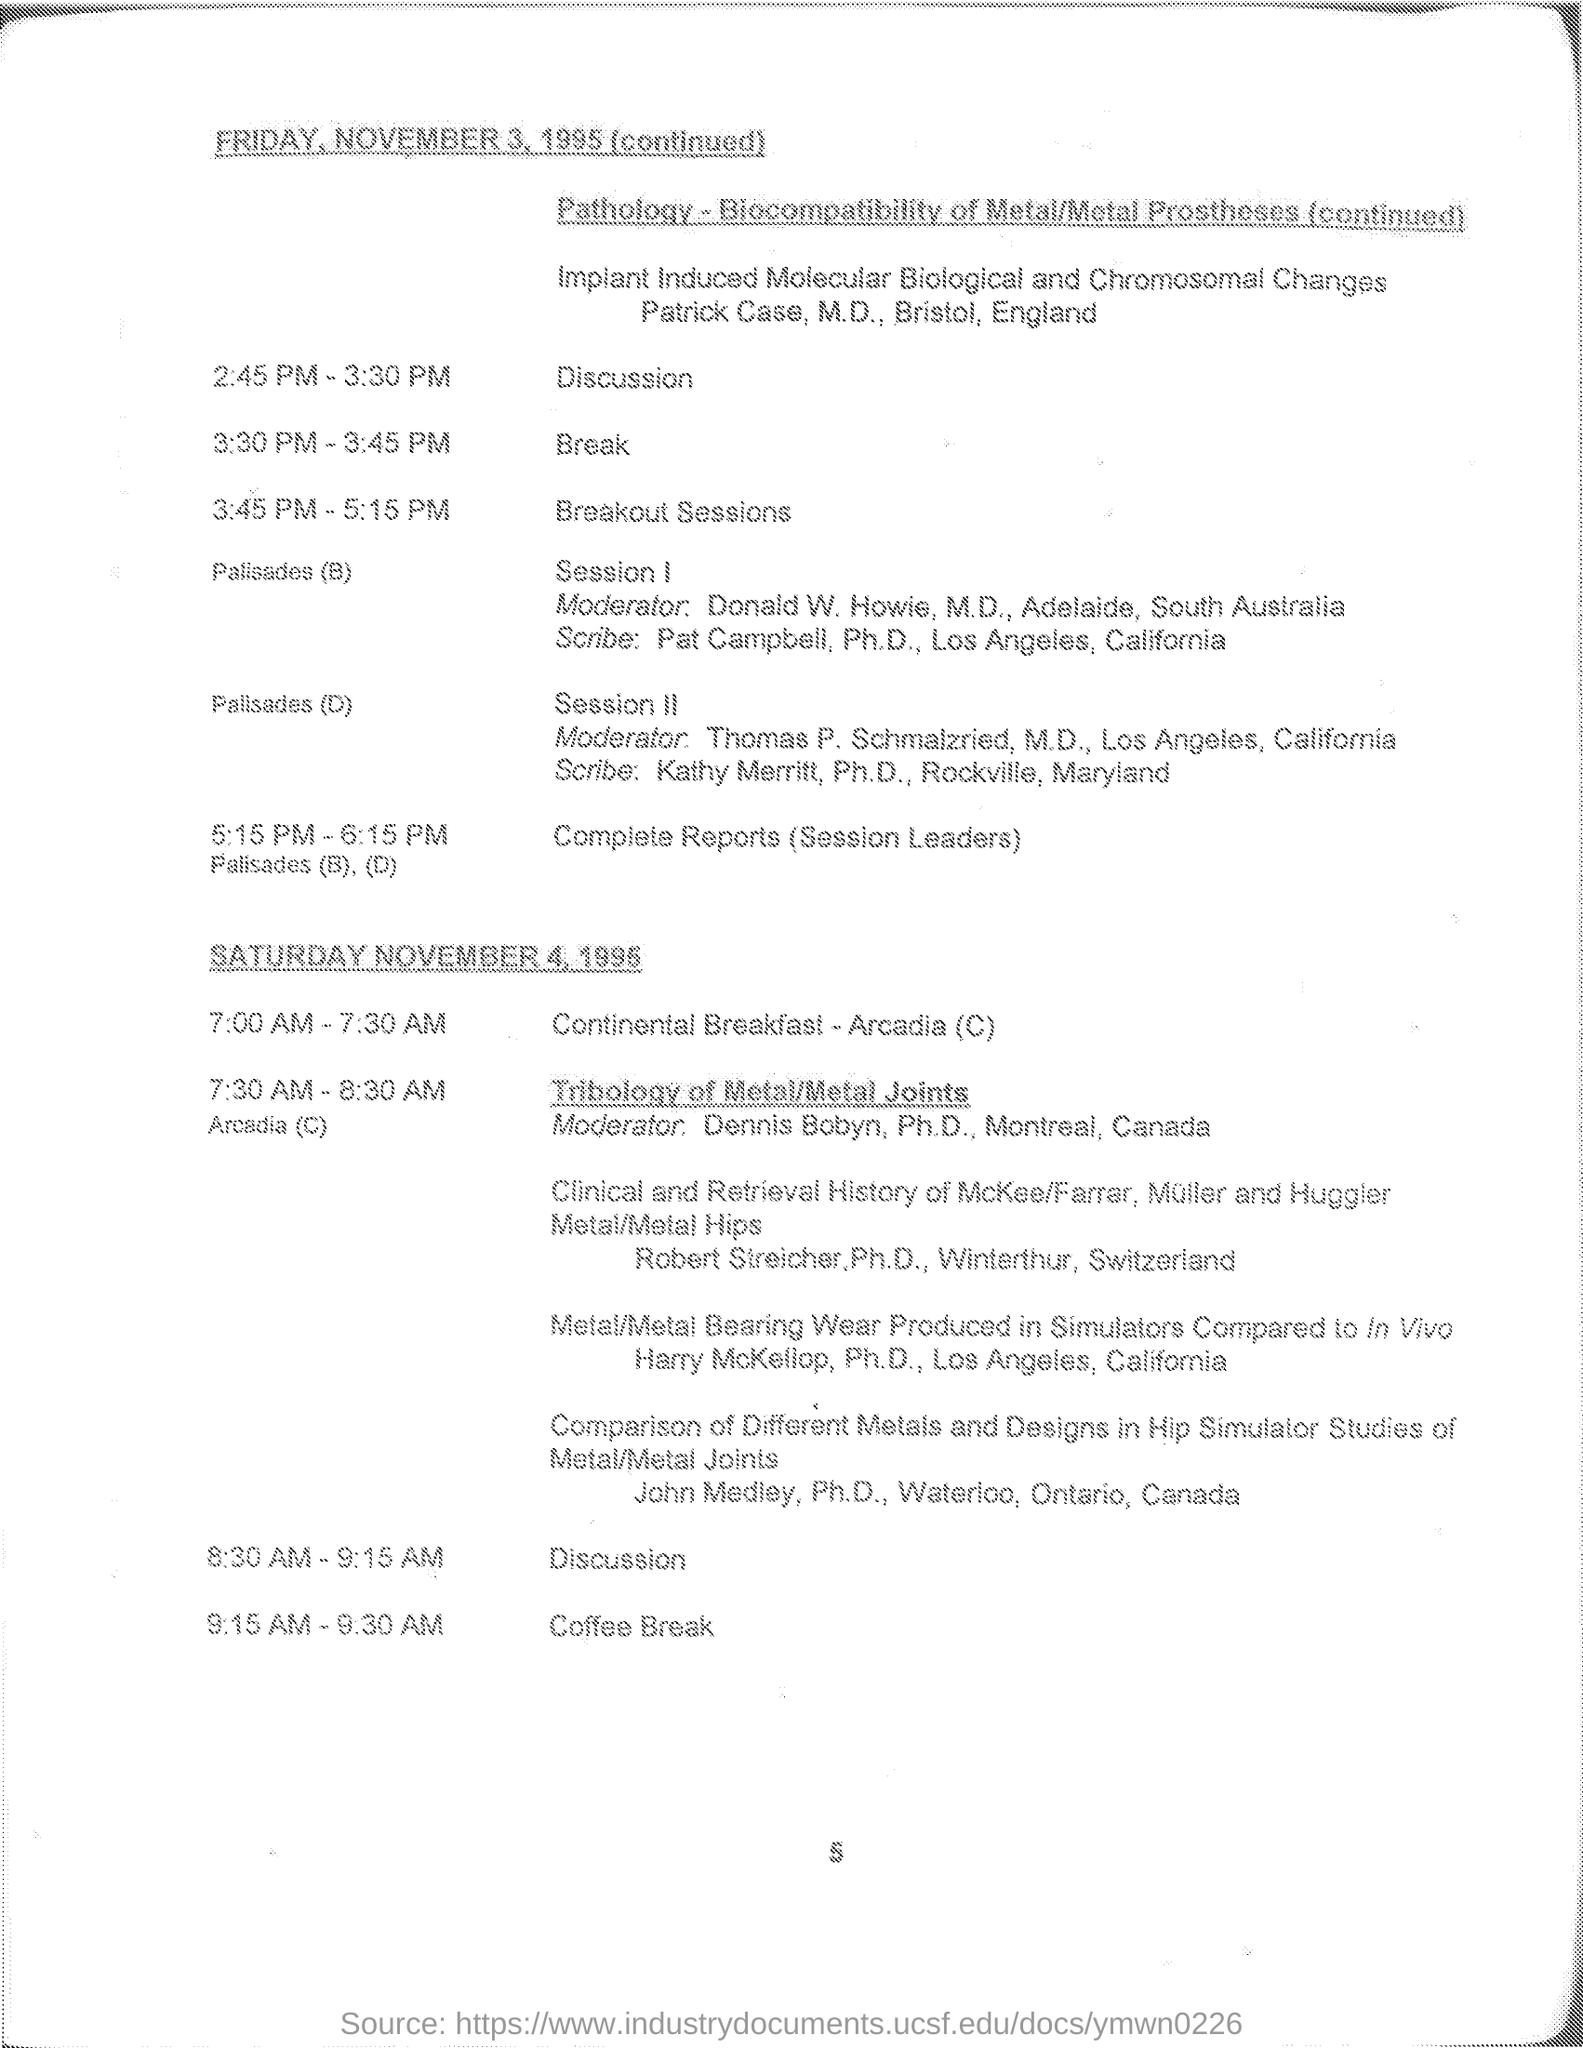When is the Break during November 3rd's program?
Your answer should be compact. 3:30 PM - 3:45 PM. When is the Breakout sessions on November 3rd?
Keep it short and to the point. 3:45 PM - 5:15PM. When is the "complete Reports (session leaders)" on November 3?
Provide a short and direct response. 5:15 PM - 6:15 PM. When is the continental breakfast?
Provide a short and direct response. 7:00 AM - 7:30 AM. When is the coffee break?
Your answer should be compact. 9:15 AM - 9:30 AM. 